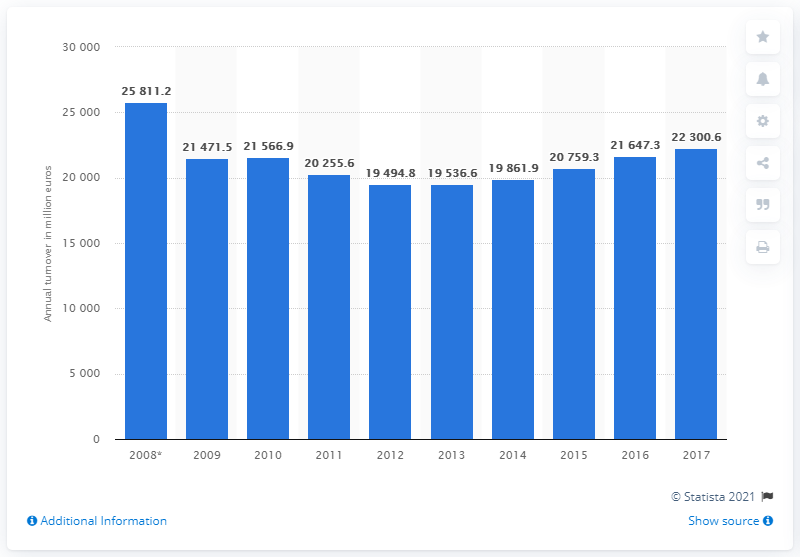Identify some key points in this picture. The turnover of Italy's furniture manufacturing in 2017 was 22,300.6 million euros. 